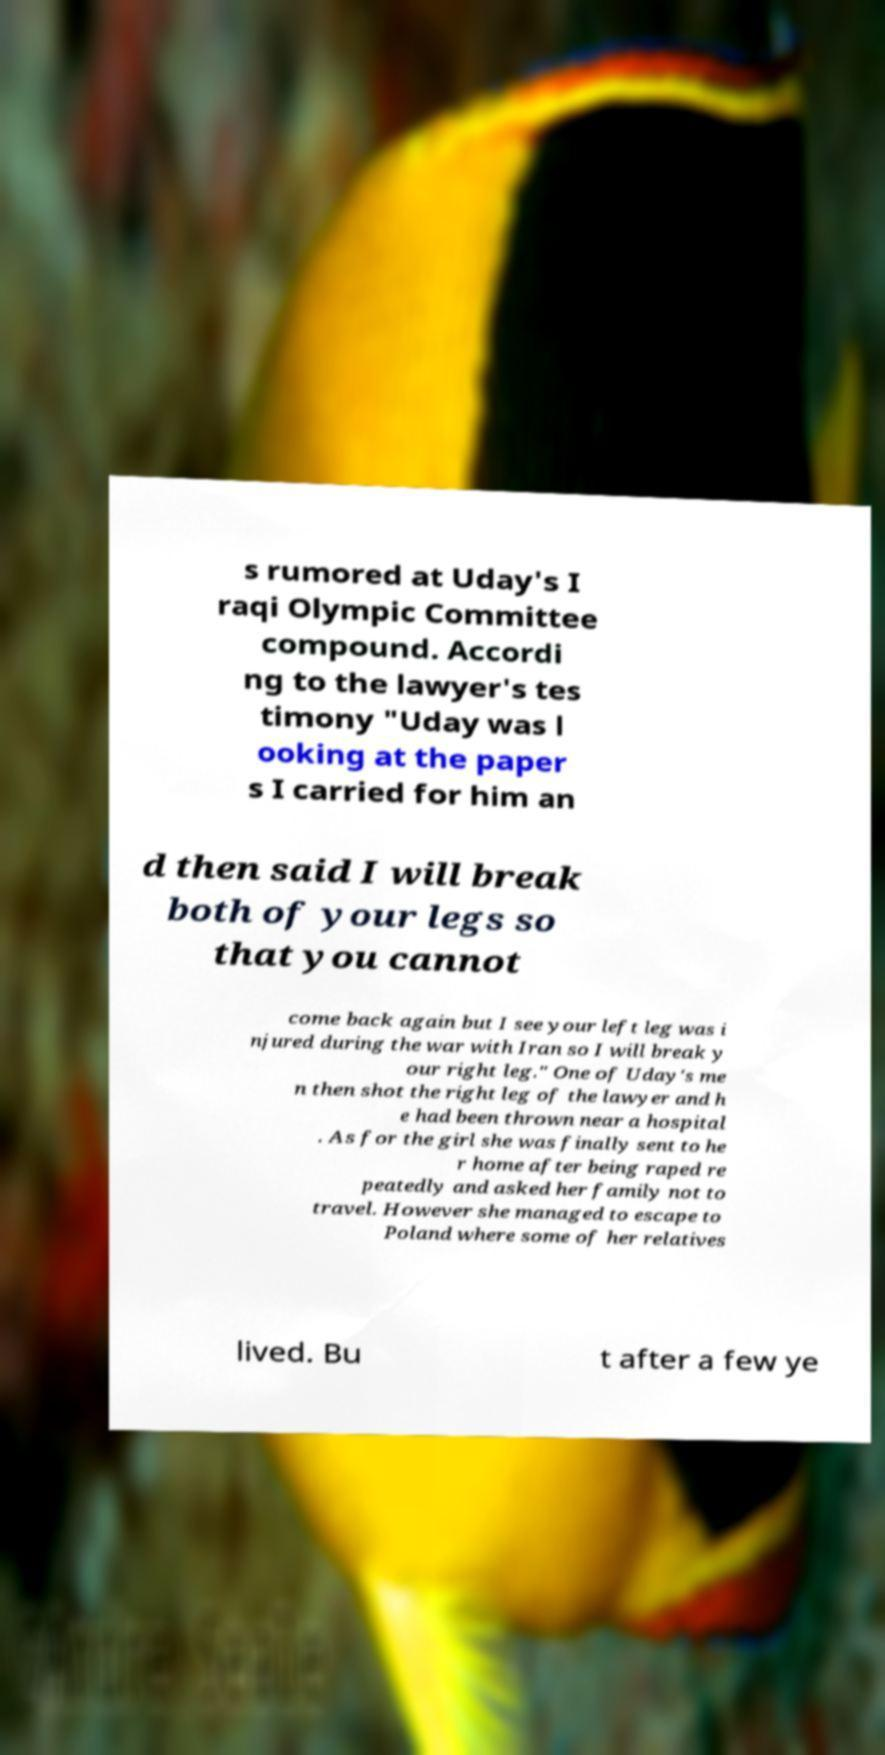Can you read and provide the text displayed in the image?This photo seems to have some interesting text. Can you extract and type it out for me? s rumored at Uday's I raqi Olympic Committee compound. Accordi ng to the lawyer's tes timony "Uday was l ooking at the paper s I carried for him an d then said I will break both of your legs so that you cannot come back again but I see your left leg was i njured during the war with Iran so I will break y our right leg." One of Uday's me n then shot the right leg of the lawyer and h e had been thrown near a hospital . As for the girl she was finally sent to he r home after being raped re peatedly and asked her family not to travel. However she managed to escape to Poland where some of her relatives lived. Bu t after a few ye 